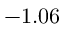Convert formula to latex. <formula><loc_0><loc_0><loc_500><loc_500>- 1 . 0 6</formula> 